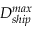Convert formula to latex. <formula><loc_0><loc_0><loc_500><loc_500>D _ { s h i p } ^ { \max }</formula> 